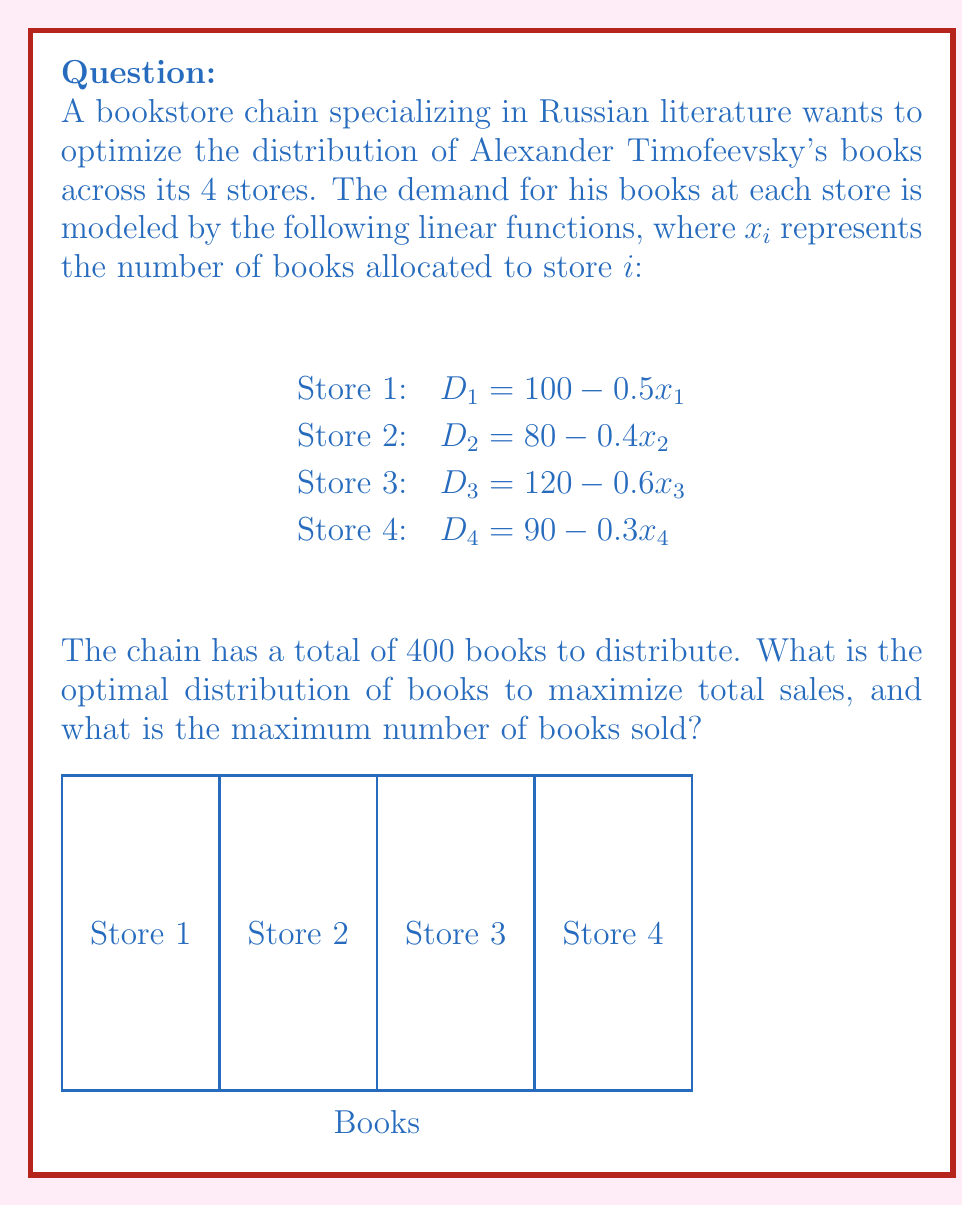Can you solve this math problem? To solve this optimization problem, we'll use the method of Lagrange multipliers:

1) Let's define the objective function as the total number of books sold:
   $$F = (100 - 0.5x_1) + (80 - 0.4x_2) + (120 - 0.6x_3) + (90 - 0.3x_4)$$

2) The constraint is:
   $$x_1 + x_2 + x_3 + x_4 = 400$$

3) Form the Lagrangian:
   $$L = F + \lambda(400 - x_1 - x_2 - x_3 - x_4)$$

4) Take partial derivatives and set them to zero:
   $$\frac{\partial L}{\partial x_1} = -0.5 - \lambda = 0$$
   $$\frac{\partial L}{\partial x_2} = -0.4 - \lambda = 0$$
   $$\frac{\partial L}{\partial x_3} = -0.6 - \lambda = 0$$
   $$\frac{\partial L}{\partial x_4} = -0.3 - \lambda = 0$$

5) From these equations, we can see that:
   $$x_1 = 2\lambda, x_2 = 2.5\lambda, x_3 = \frac{5}{3}\lambda, x_4 = \frac{10}{3}\lambda$$

6) Substitute these into the constraint equation:
   $$2\lambda + 2.5\lambda + \frac{5}{3}\lambda + \frac{10}{3}\lambda = 400$$
   $$\frac{55}{6}\lambda = 400$$
   $$\lambda = \frac{2400}{55} \approx 43.64$$

7) Now we can calculate the optimal distribution:
   $$x_1 = 2(43.64) \approx 87.28$$
   $$x_2 = 2.5(43.64) \approx 109.10$$
   $$x_3 = \frac{5}{3}(43.64) \approx 72.73$$
   $$x_4 = \frac{10}{3}(43.64) \approx 145.47$$

8) Rounding to the nearest whole number (as we can't have fractional books):
   $$x_1 = 87, x_2 = 109, x_3 = 73, x_4 = 131$$

9) The maximum number of books sold is:
   $$(100 - 0.5(87)) + (80 - 0.4(109)) + (120 - 0.6(73)) + (90 - 0.3(131)) \approx 341.7$$
Answer: Optimal distribution: 87, 109, 73, 131 books for stores 1-4 respectively. Maximum books sold: 342 (rounded up). 